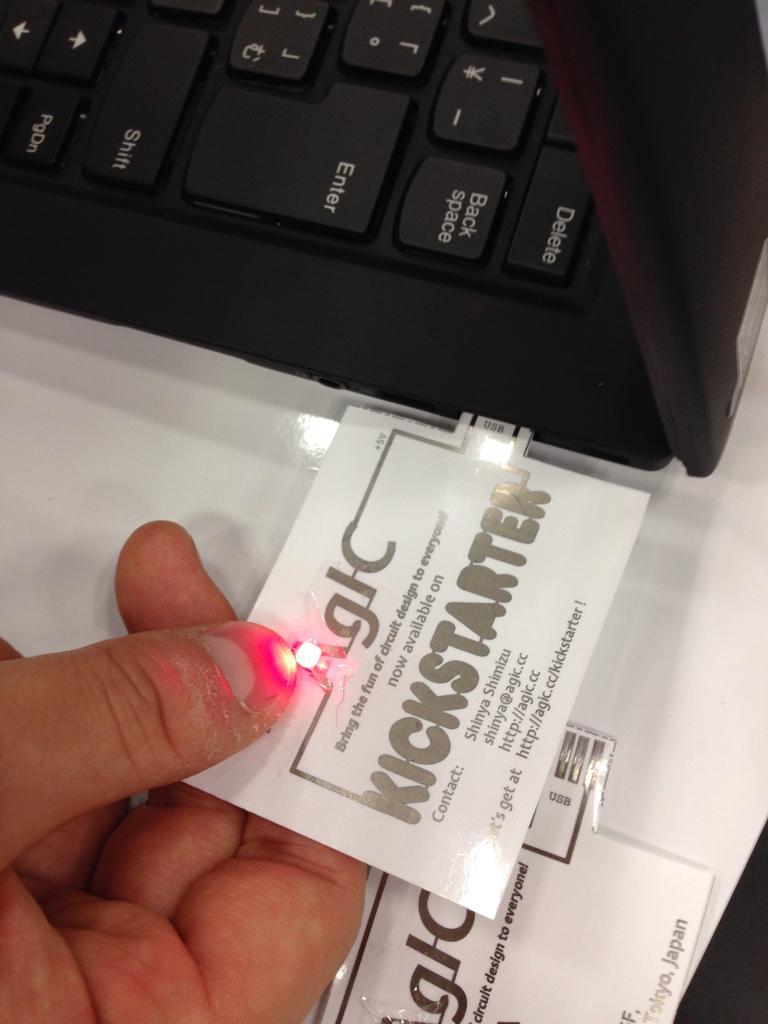In one or two sentences, can you explain what this image depicts? In this image, we can see a person hand holding a chip. There is a laptop at the top of the image. There is an another chip at the bottom of the image. 